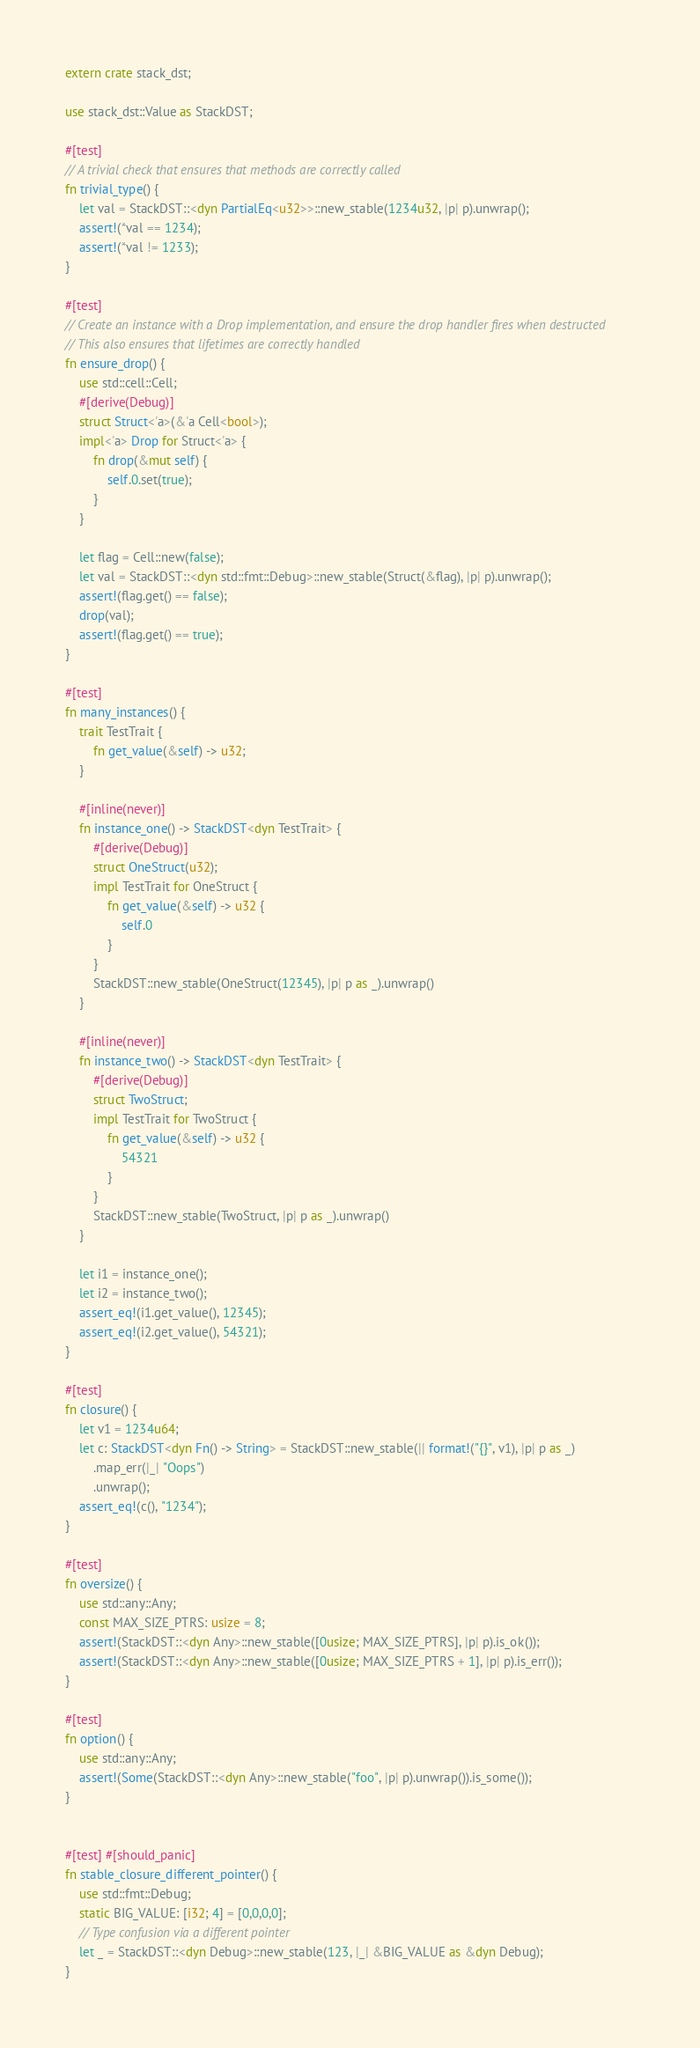Convert code to text. <code><loc_0><loc_0><loc_500><loc_500><_Rust_>extern crate stack_dst;

use stack_dst::Value as StackDST;

#[test]
// A trivial check that ensures that methods are correctly called
fn trivial_type() {
    let val = StackDST::<dyn PartialEq<u32>>::new_stable(1234u32, |p| p).unwrap();
    assert!(*val == 1234);
    assert!(*val != 1233);
}

#[test]
// Create an instance with a Drop implementation, and ensure the drop handler fires when destructed
// This also ensures that lifetimes are correctly handled
fn ensure_drop() {
    use std::cell::Cell;
    #[derive(Debug)]
    struct Struct<'a>(&'a Cell<bool>);
    impl<'a> Drop for Struct<'a> {
        fn drop(&mut self) {
            self.0.set(true);
        }
    }

    let flag = Cell::new(false);
    let val = StackDST::<dyn std::fmt::Debug>::new_stable(Struct(&flag), |p| p).unwrap();
    assert!(flag.get() == false);
    drop(val);
    assert!(flag.get() == true);
}

#[test]
fn many_instances() {
    trait TestTrait {
        fn get_value(&self) -> u32;
    }

    #[inline(never)]
    fn instance_one() -> StackDST<dyn TestTrait> {
        #[derive(Debug)]
        struct OneStruct(u32);
        impl TestTrait for OneStruct {
            fn get_value(&self) -> u32 {
                self.0
            }
        }
        StackDST::new_stable(OneStruct(12345), |p| p as _).unwrap()
    }

    #[inline(never)]
    fn instance_two() -> StackDST<dyn TestTrait> {
        #[derive(Debug)]
        struct TwoStruct;
        impl TestTrait for TwoStruct {
            fn get_value(&self) -> u32 {
                54321
            }
        }
        StackDST::new_stable(TwoStruct, |p| p as _).unwrap()
    }

    let i1 = instance_one();
    let i2 = instance_two();
    assert_eq!(i1.get_value(), 12345);
    assert_eq!(i2.get_value(), 54321);
}

#[test]
fn closure() {
    let v1 = 1234u64;
    let c: StackDST<dyn Fn() -> String> = StackDST::new_stable(|| format!("{}", v1), |p| p as _)
        .map_err(|_| "Oops")
        .unwrap();
    assert_eq!(c(), "1234");
}

#[test]
fn oversize() {
    use std::any::Any;
    const MAX_SIZE_PTRS: usize = 8;
    assert!(StackDST::<dyn Any>::new_stable([0usize; MAX_SIZE_PTRS], |p| p).is_ok());
    assert!(StackDST::<dyn Any>::new_stable([0usize; MAX_SIZE_PTRS + 1], |p| p).is_err());
}

#[test]
fn option() {
    use std::any::Any;
    assert!(Some(StackDST::<dyn Any>::new_stable("foo", |p| p).unwrap()).is_some());
}


#[test] #[should_panic]
fn stable_closure_different_pointer() {
    use std::fmt::Debug;
	static BIG_VALUE: [i32; 4] = [0,0,0,0];
	// Type confusion via a different pointer
	let _ = StackDST::<dyn Debug>::new_stable(123, |_| &BIG_VALUE as &dyn Debug);
}</code> 